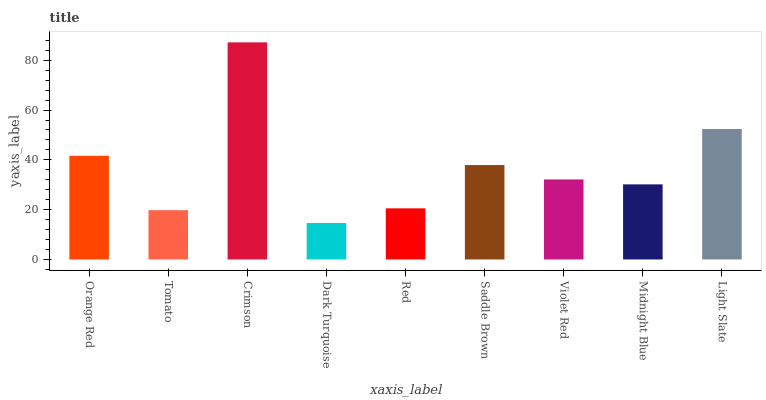Is Dark Turquoise the minimum?
Answer yes or no. Yes. Is Crimson the maximum?
Answer yes or no. Yes. Is Tomato the minimum?
Answer yes or no. No. Is Tomato the maximum?
Answer yes or no. No. Is Orange Red greater than Tomato?
Answer yes or no. Yes. Is Tomato less than Orange Red?
Answer yes or no. Yes. Is Tomato greater than Orange Red?
Answer yes or no. No. Is Orange Red less than Tomato?
Answer yes or no. No. Is Violet Red the high median?
Answer yes or no. Yes. Is Violet Red the low median?
Answer yes or no. Yes. Is Tomato the high median?
Answer yes or no. No. Is Light Slate the low median?
Answer yes or no. No. 